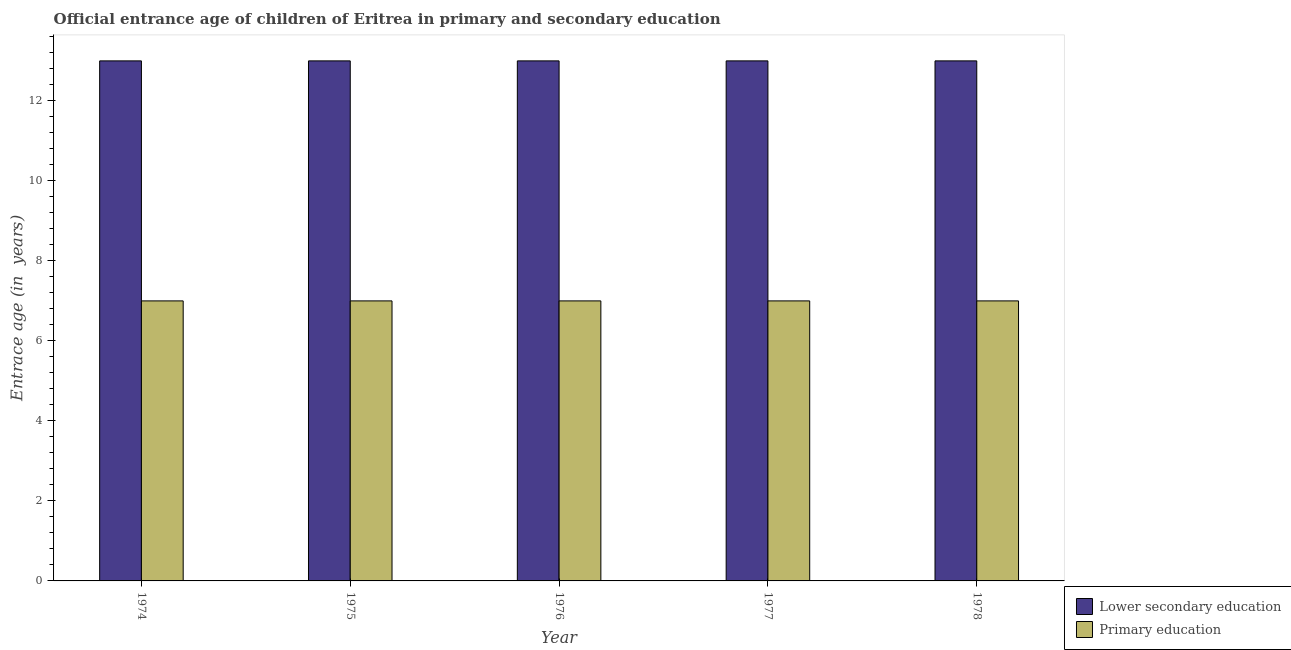How many groups of bars are there?
Provide a short and direct response. 5. Are the number of bars on each tick of the X-axis equal?
Provide a short and direct response. Yes. What is the label of the 1st group of bars from the left?
Make the answer very short. 1974. What is the entrance age of children in lower secondary education in 1974?
Provide a succinct answer. 13. Across all years, what is the maximum entrance age of chiildren in primary education?
Give a very brief answer. 7. Across all years, what is the minimum entrance age of children in lower secondary education?
Your response must be concise. 13. In which year was the entrance age of children in lower secondary education maximum?
Offer a very short reply. 1974. In which year was the entrance age of chiildren in primary education minimum?
Provide a succinct answer. 1974. What is the total entrance age of chiildren in primary education in the graph?
Offer a terse response. 35. In how many years, is the entrance age of chiildren in primary education greater than 5.2 years?
Offer a terse response. 5. What is the difference between the highest and the second highest entrance age of children in lower secondary education?
Your answer should be very brief. 0. What is the difference between the highest and the lowest entrance age of children in lower secondary education?
Your answer should be very brief. 0. Is the sum of the entrance age of chiildren in primary education in 1976 and 1978 greater than the maximum entrance age of children in lower secondary education across all years?
Provide a succinct answer. Yes. How many bars are there?
Your answer should be compact. 10. How many years are there in the graph?
Provide a succinct answer. 5. What is the difference between two consecutive major ticks on the Y-axis?
Give a very brief answer. 2. Are the values on the major ticks of Y-axis written in scientific E-notation?
Provide a succinct answer. No. Does the graph contain grids?
Offer a very short reply. No. What is the title of the graph?
Your answer should be very brief. Official entrance age of children of Eritrea in primary and secondary education. What is the label or title of the X-axis?
Give a very brief answer. Year. What is the label or title of the Y-axis?
Offer a terse response. Entrace age (in  years). What is the Entrace age (in  years) in Primary education in 1974?
Offer a very short reply. 7. What is the Entrace age (in  years) in Lower secondary education in 1977?
Your answer should be compact. 13. What is the Entrace age (in  years) of Primary education in 1978?
Your answer should be compact. 7. Across all years, what is the minimum Entrace age (in  years) in Primary education?
Your response must be concise. 7. What is the total Entrace age (in  years) of Primary education in the graph?
Offer a very short reply. 35. What is the difference between the Entrace age (in  years) in Lower secondary education in 1974 and that in 1975?
Provide a short and direct response. 0. What is the difference between the Entrace age (in  years) in Primary education in 1974 and that in 1975?
Offer a very short reply. 0. What is the difference between the Entrace age (in  years) in Lower secondary education in 1974 and that in 1976?
Your answer should be very brief. 0. What is the difference between the Entrace age (in  years) in Primary education in 1974 and that in 1976?
Offer a terse response. 0. What is the difference between the Entrace age (in  years) of Lower secondary education in 1974 and that in 1977?
Provide a succinct answer. 0. What is the difference between the Entrace age (in  years) of Primary education in 1974 and that in 1978?
Provide a succinct answer. 0. What is the difference between the Entrace age (in  years) in Lower secondary education in 1975 and that in 1976?
Give a very brief answer. 0. What is the difference between the Entrace age (in  years) of Primary education in 1975 and that in 1976?
Ensure brevity in your answer.  0. What is the difference between the Entrace age (in  years) of Primary education in 1975 and that in 1978?
Give a very brief answer. 0. What is the difference between the Entrace age (in  years) in Primary education in 1976 and that in 1977?
Make the answer very short. 0. What is the difference between the Entrace age (in  years) of Lower secondary education in 1976 and that in 1978?
Offer a very short reply. 0. What is the difference between the Entrace age (in  years) of Primary education in 1976 and that in 1978?
Offer a very short reply. 0. What is the difference between the Entrace age (in  years) of Lower secondary education in 1977 and that in 1978?
Your answer should be compact. 0. What is the difference between the Entrace age (in  years) in Lower secondary education in 1974 and the Entrace age (in  years) in Primary education in 1975?
Give a very brief answer. 6. What is the difference between the Entrace age (in  years) in Lower secondary education in 1974 and the Entrace age (in  years) in Primary education in 1977?
Offer a terse response. 6. What is the difference between the Entrace age (in  years) in Lower secondary education in 1974 and the Entrace age (in  years) in Primary education in 1978?
Keep it short and to the point. 6. What is the difference between the Entrace age (in  years) of Lower secondary education in 1975 and the Entrace age (in  years) of Primary education in 1976?
Provide a succinct answer. 6. What is the difference between the Entrace age (in  years) in Lower secondary education in 1976 and the Entrace age (in  years) in Primary education in 1977?
Your response must be concise. 6. What is the difference between the Entrace age (in  years) of Lower secondary education in 1976 and the Entrace age (in  years) of Primary education in 1978?
Your answer should be very brief. 6. What is the average Entrace age (in  years) in Primary education per year?
Your answer should be compact. 7. In the year 1974, what is the difference between the Entrace age (in  years) of Lower secondary education and Entrace age (in  years) of Primary education?
Provide a succinct answer. 6. In the year 1976, what is the difference between the Entrace age (in  years) of Lower secondary education and Entrace age (in  years) of Primary education?
Offer a very short reply. 6. In the year 1978, what is the difference between the Entrace age (in  years) of Lower secondary education and Entrace age (in  years) of Primary education?
Ensure brevity in your answer.  6. What is the ratio of the Entrace age (in  years) of Lower secondary education in 1974 to that in 1975?
Your answer should be very brief. 1. What is the ratio of the Entrace age (in  years) in Primary education in 1974 to that in 1975?
Your response must be concise. 1. What is the ratio of the Entrace age (in  years) in Primary education in 1974 to that in 1976?
Keep it short and to the point. 1. What is the ratio of the Entrace age (in  years) in Primary education in 1974 to that in 1978?
Keep it short and to the point. 1. What is the ratio of the Entrace age (in  years) in Primary education in 1975 to that in 1977?
Provide a short and direct response. 1. What is the ratio of the Entrace age (in  years) of Lower secondary education in 1975 to that in 1978?
Offer a very short reply. 1. What is the ratio of the Entrace age (in  years) in Primary education in 1975 to that in 1978?
Offer a terse response. 1. What is the ratio of the Entrace age (in  years) of Primary education in 1976 to that in 1977?
Make the answer very short. 1. What is the ratio of the Entrace age (in  years) of Lower secondary education in 1977 to that in 1978?
Your answer should be very brief. 1. What is the ratio of the Entrace age (in  years) in Primary education in 1977 to that in 1978?
Provide a succinct answer. 1. What is the difference between the highest and the second highest Entrace age (in  years) of Primary education?
Offer a very short reply. 0. 